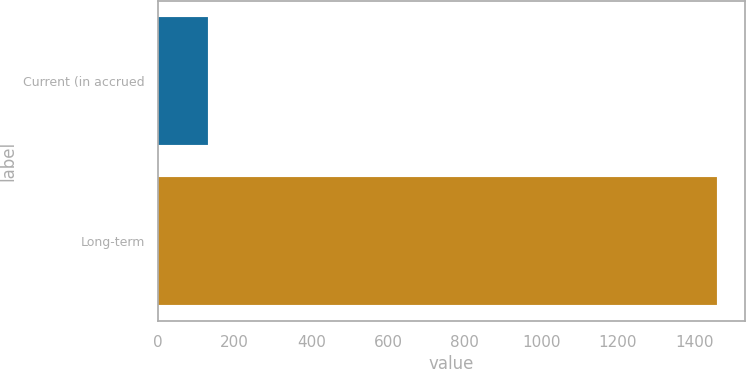Convert chart. <chart><loc_0><loc_0><loc_500><loc_500><bar_chart><fcel>Current (in accrued<fcel>Long-term<nl><fcel>132<fcel>1459<nl></chart> 